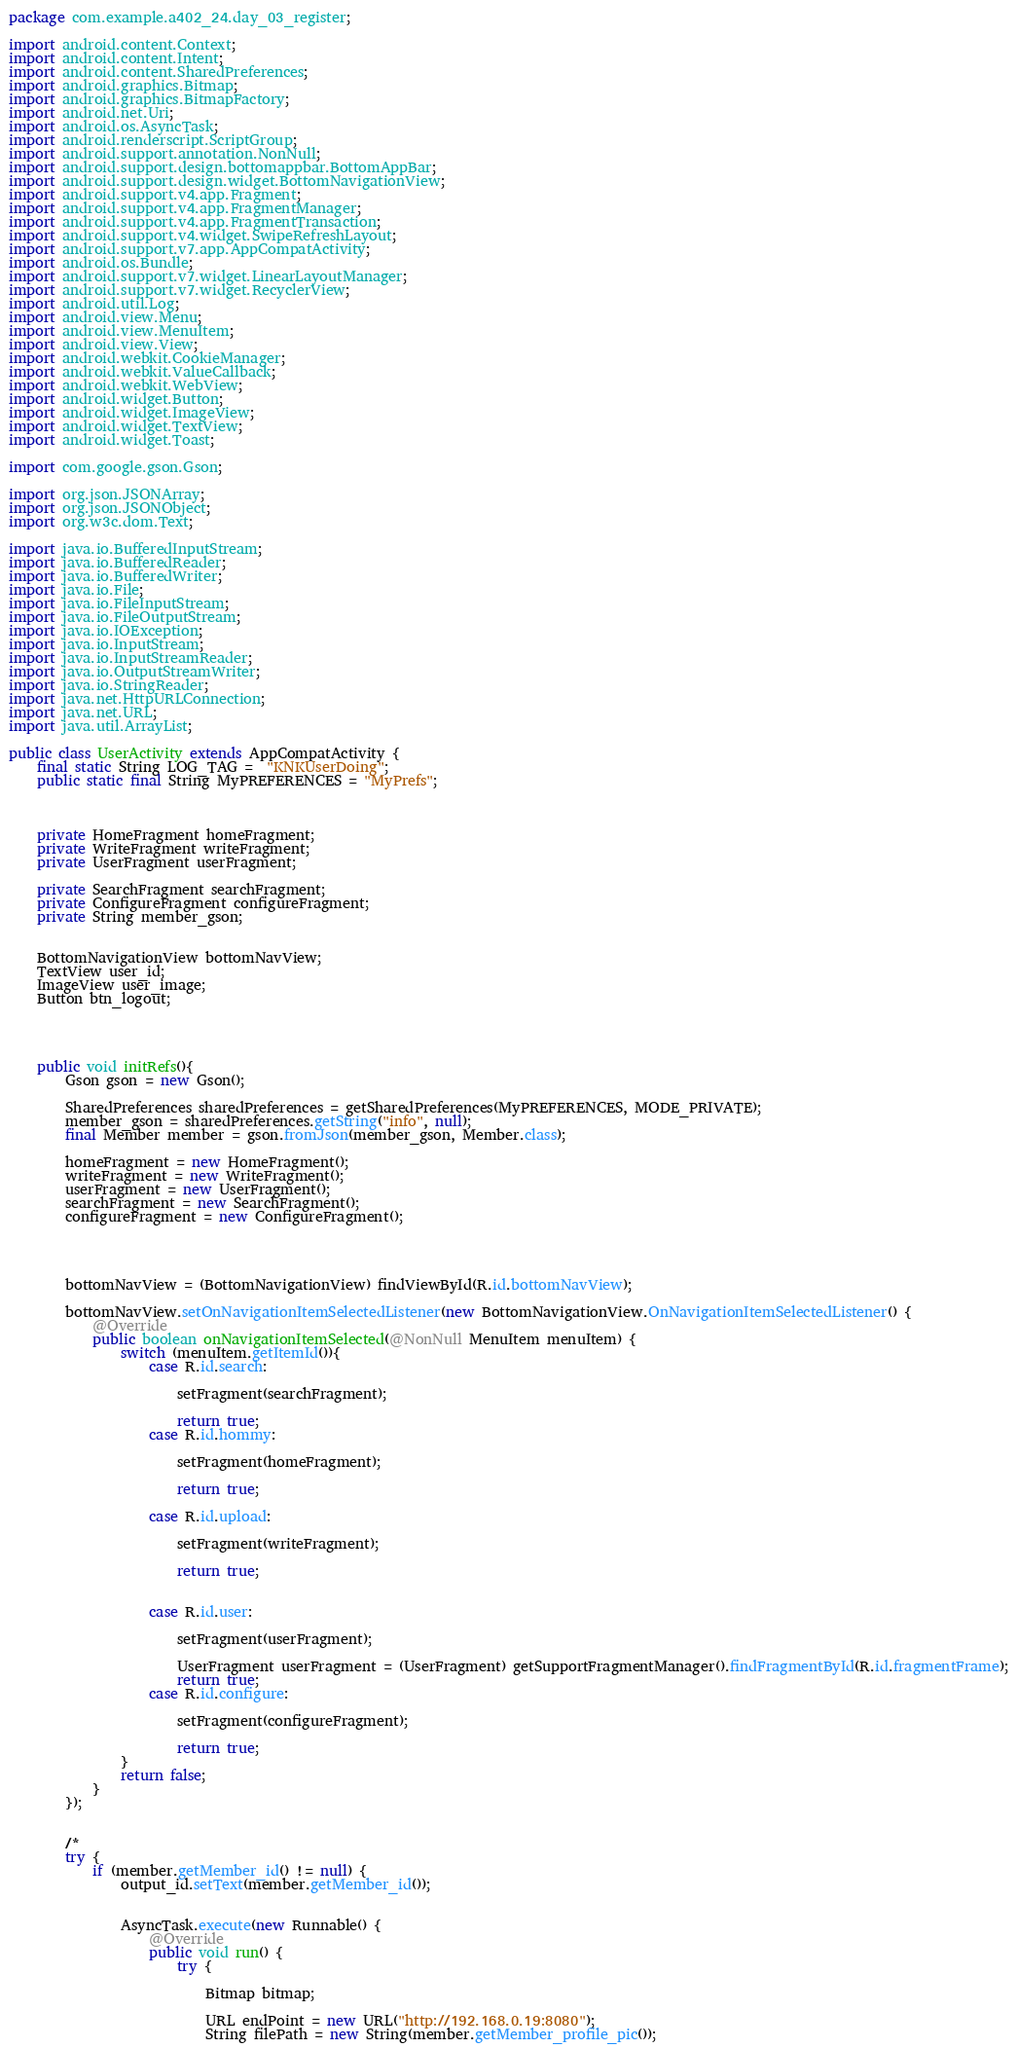<code> <loc_0><loc_0><loc_500><loc_500><_Java_>package com.example.a402_24.day_03_register;

import android.content.Context;
import android.content.Intent;
import android.content.SharedPreferences;
import android.graphics.Bitmap;
import android.graphics.BitmapFactory;
import android.net.Uri;
import android.os.AsyncTask;
import android.renderscript.ScriptGroup;
import android.support.annotation.NonNull;
import android.support.design.bottomappbar.BottomAppBar;
import android.support.design.widget.BottomNavigationView;
import android.support.v4.app.Fragment;
import android.support.v4.app.FragmentManager;
import android.support.v4.app.FragmentTransaction;
import android.support.v4.widget.SwipeRefreshLayout;
import android.support.v7.app.AppCompatActivity;
import android.os.Bundle;
import android.support.v7.widget.LinearLayoutManager;
import android.support.v7.widget.RecyclerView;
import android.util.Log;
import android.view.Menu;
import android.view.MenuItem;
import android.view.View;
import android.webkit.CookieManager;
import android.webkit.ValueCallback;
import android.webkit.WebView;
import android.widget.Button;
import android.widget.ImageView;
import android.widget.TextView;
import android.widget.Toast;

import com.google.gson.Gson;

import org.json.JSONArray;
import org.json.JSONObject;
import org.w3c.dom.Text;

import java.io.BufferedInputStream;
import java.io.BufferedReader;
import java.io.BufferedWriter;
import java.io.File;
import java.io.FileInputStream;
import java.io.FileOutputStream;
import java.io.IOException;
import java.io.InputStream;
import java.io.InputStreamReader;
import java.io.OutputStreamWriter;
import java.io.StringReader;
import java.net.HttpURLConnection;
import java.net.URL;
import java.util.ArrayList;

public class UserActivity extends AppCompatActivity {
    final static String LOG_TAG =  "KNKUserDoing";
    public static final String MyPREFERENCES = "MyPrefs";



    private HomeFragment homeFragment;
    private WriteFragment writeFragment;
    private UserFragment userFragment;

    private SearchFragment searchFragment;
    private ConfigureFragment configureFragment;
    private String member_gson;


    BottomNavigationView bottomNavView;
    TextView user_id;
    ImageView user_image;
    Button btn_logout;




    public void initRefs(){
        Gson gson = new Gson();

        SharedPreferences sharedPreferences = getSharedPreferences(MyPREFERENCES, MODE_PRIVATE);
        member_gson = sharedPreferences.getString("info", null);
        final Member member = gson.fromJson(member_gson, Member.class);

        homeFragment = new HomeFragment();
        writeFragment = new WriteFragment();
        userFragment = new UserFragment();
        searchFragment = new SearchFragment();
        configureFragment = new ConfigureFragment();




        bottomNavView = (BottomNavigationView) findViewById(R.id.bottomNavView);

        bottomNavView.setOnNavigationItemSelectedListener(new BottomNavigationView.OnNavigationItemSelectedListener() {
            @Override
            public boolean onNavigationItemSelected(@NonNull MenuItem menuItem) {
                switch (menuItem.getItemId()){
                    case R.id.search:

                        setFragment(searchFragment);

                        return true;
                    case R.id.hommy:

                        setFragment(homeFragment);

                        return true;

                    case R.id.upload:

                        setFragment(writeFragment);

                        return true;


                    case R.id.user:

                        setFragment(userFragment);

                        UserFragment userFragment = (UserFragment) getSupportFragmentManager().findFragmentById(R.id.fragmentFrame);
                        return true;
                    case R.id.configure:

                        setFragment(configureFragment);

                        return true;
                }
                return false;
            }
        });


        /*
        try {
            if (member.getMember_id() != null) {
                output_id.setText(member.getMember_id());


                AsyncTask.execute(new Runnable() {
                    @Override
                    public void run() {
                        try {

                            Bitmap bitmap;

                            URL endPoint = new URL("http://192.168.0.19:8080");
                            String filePath = new String(member.getMember_profile_pic());</code> 